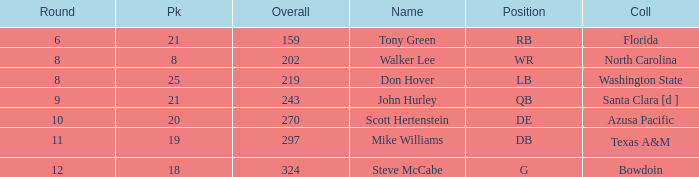Which college has a pick less than 25, an overall greater than 159, a round less than 10, and wr as the position? North Carolina. 